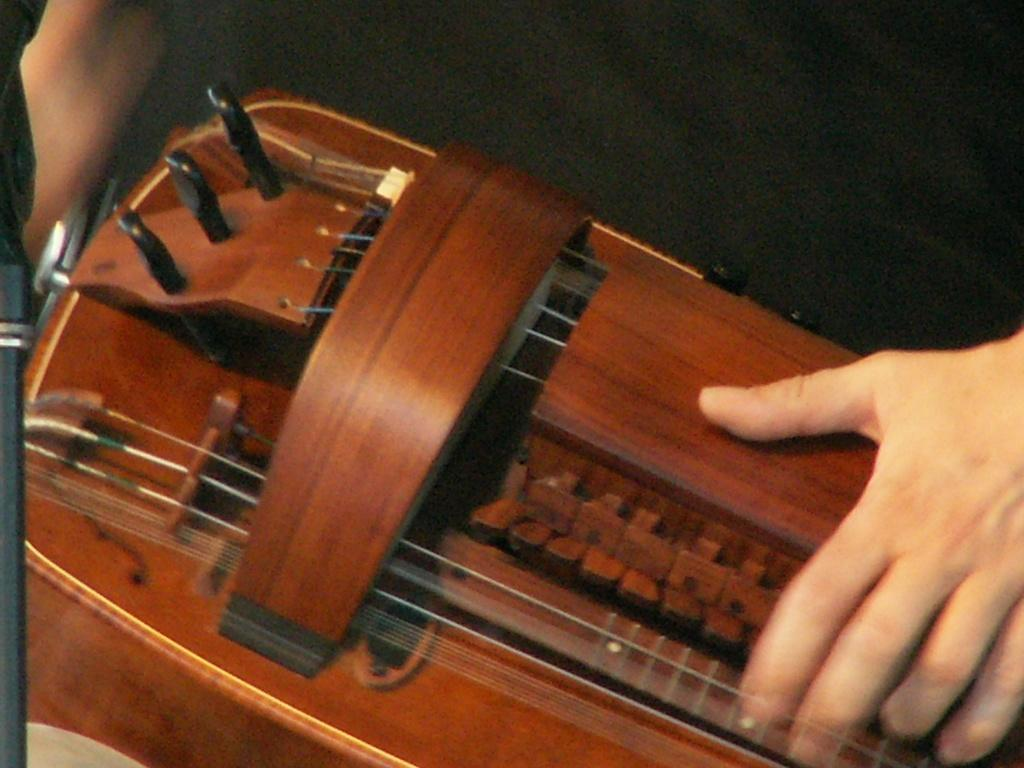What activity is being performed in the image? There are hands playing a musical instrument in the image. What is the color of the musical instrument? The musical instrument is brown in color. Can you describe a specific feature of the musical instrument? There is a black part at the top of the musical instrument. How many jars are visible on the table in the image? There are no jars present in the image; the focus is on the hands playing a musical instrument. 